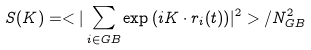<formula> <loc_0><loc_0><loc_500><loc_500>S ( { K } ) = < | \sum _ { i \in G B } \exp { ( i { K } \cdot { r } _ { i } ( t ) ) } | ^ { 2 } > / N _ { G B } ^ { 2 }</formula> 